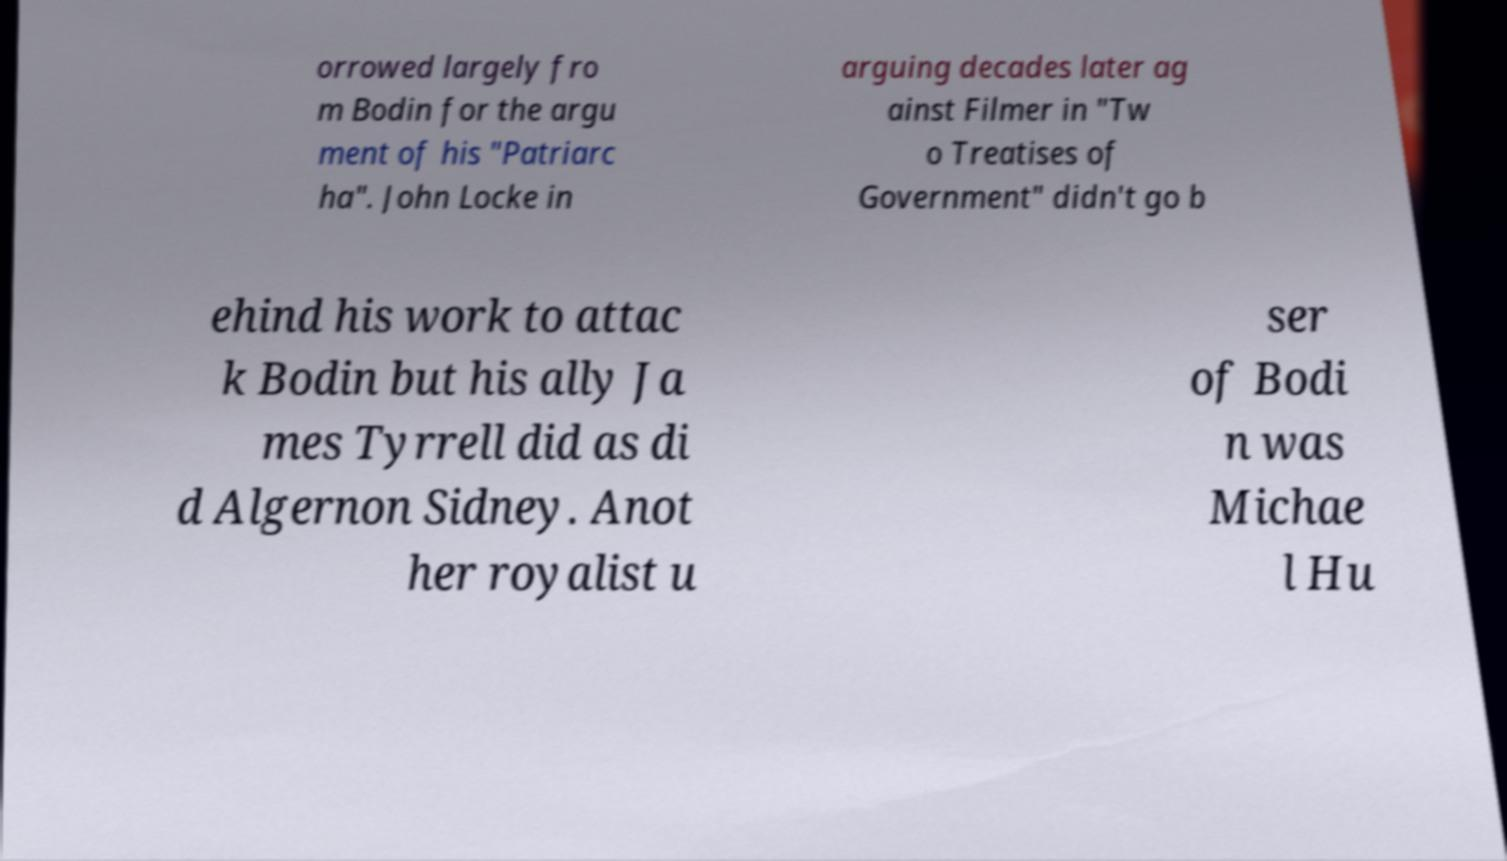I need the written content from this picture converted into text. Can you do that? orrowed largely fro m Bodin for the argu ment of his "Patriarc ha". John Locke in arguing decades later ag ainst Filmer in "Tw o Treatises of Government" didn't go b ehind his work to attac k Bodin but his ally Ja mes Tyrrell did as di d Algernon Sidney. Anot her royalist u ser of Bodi n was Michae l Hu 